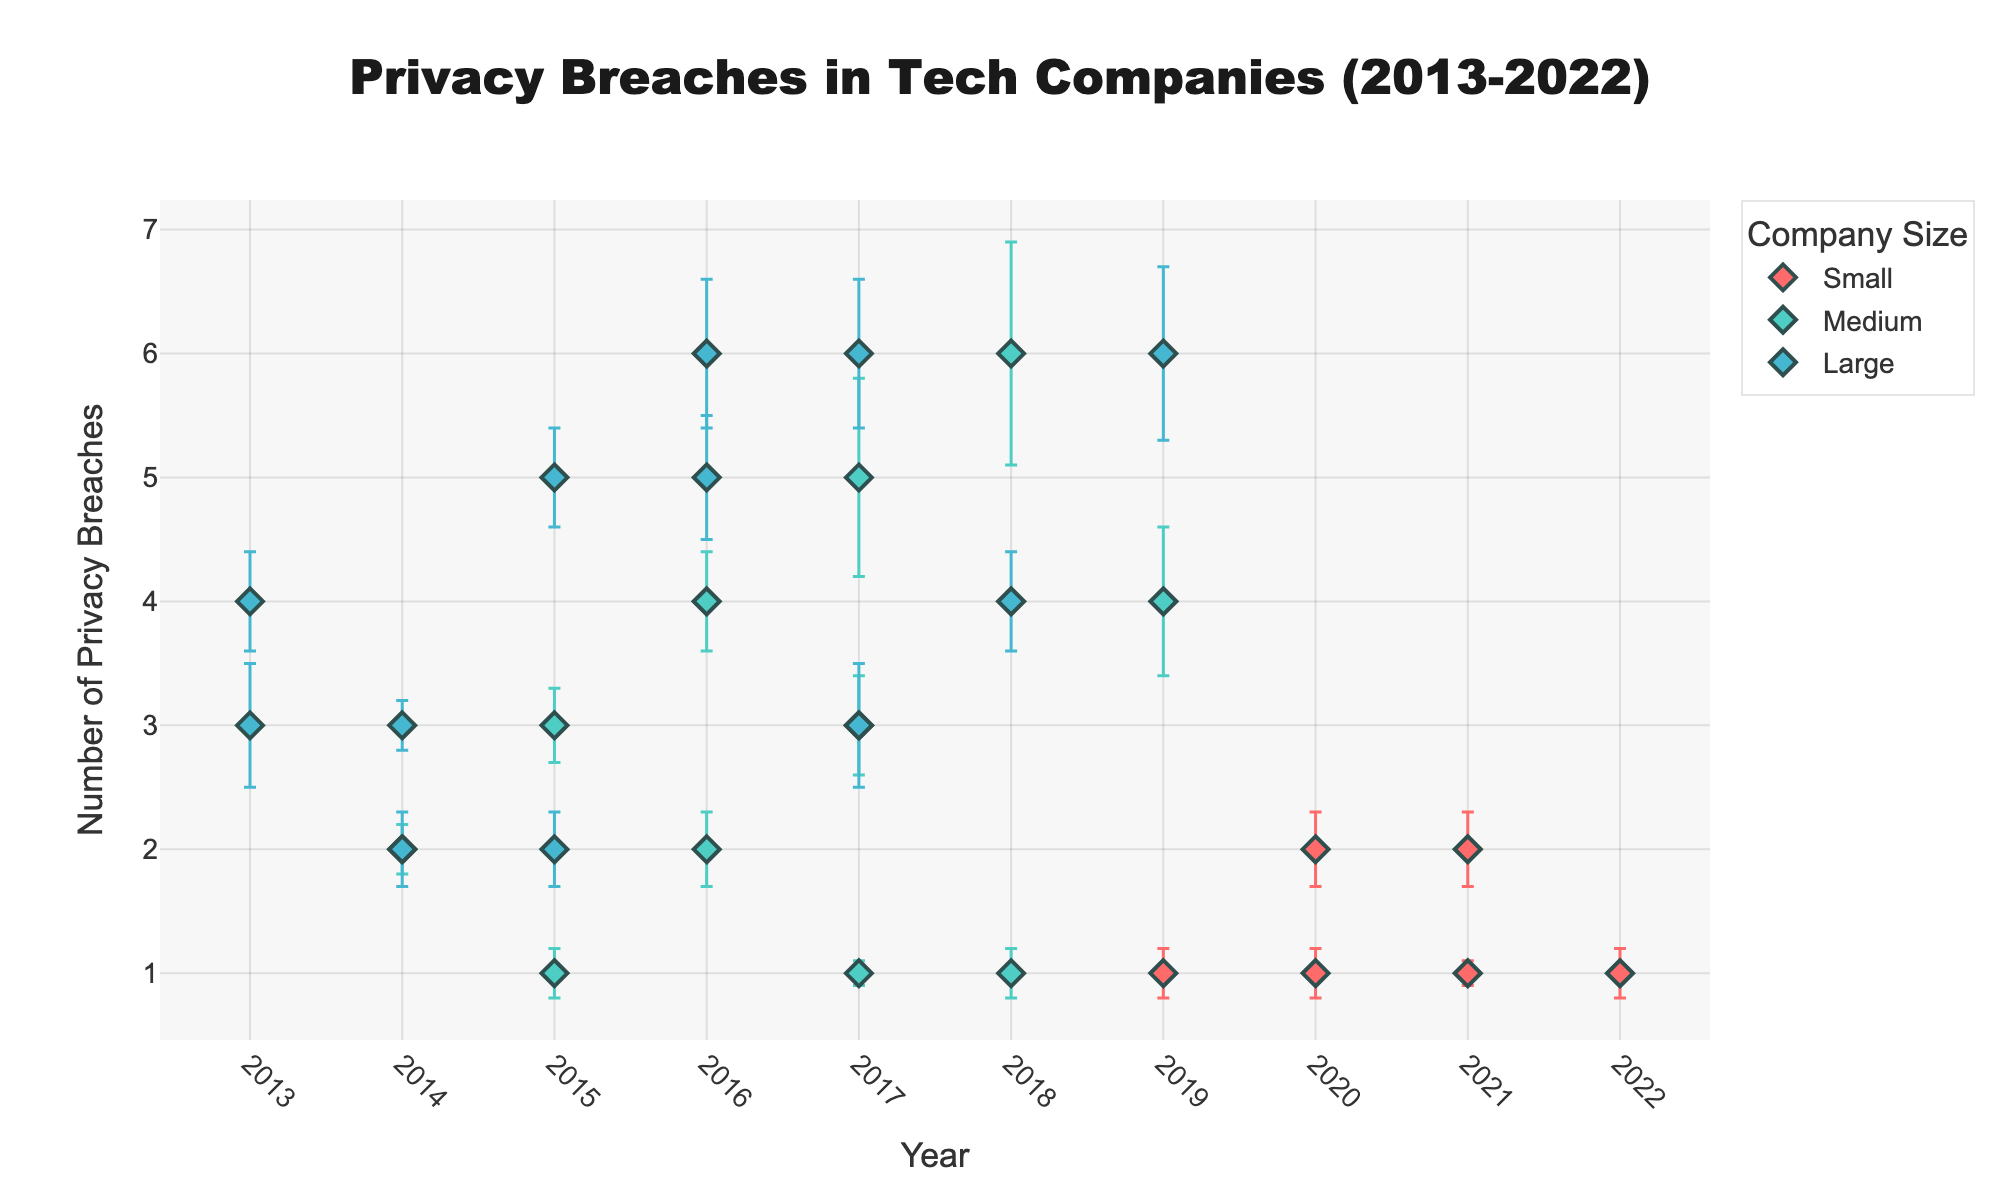what is the title of the plot? The title is usually displayed at the top of the plot, center-aligned. It provides a brief description of what the figure represents.
Answer: Privacy Breaches in Tech Companies (2013-2022) What is the y-axis title? The y-axis title is found along the vertical axis and indicates what is being measured in this direction.
Answer: Number of Privacy Breaches Which years show privacy breaches for small companies? The x-axis represents the years. Look at the plot and identify the years corresponding to the data points colored for small companies.
Answer: 2019, 2020, 2021, 2022 How many privacy breaches did Facebook have in 2016? Find the data point for Facebook (large company size) in 2016 on the x-axis and refer to the y-axis value at that point.
Answer: 6 Which company size had the lowest privacy breaches in 2017? Compare the data points for different company sizes for the year 2017 on the x-axis and determine which has the lowest value on the y-axis.
Answer: Medium What is the average number of privacy breaches for Google from 2013 to 2017? Find Google's privacy breaches data points for each year from 2013 to 2017 and calculate the average: (4+3+2+5+6)/5 = 20/5.
Answer: 4 Which company had the highest privacy breaches in 2019? Look for the data points belonging to different companies for the year 2019, identify the one with the highest y-axis value.
Answer: Alibaba In which year does Equifax have the highest privacy breaches and what is the value? Look at the data points for Equifax (medium company size) across the years and determine the year with the highest y-axis value and the corresponding number.
Answer: 2018, 6 How does the privacy breach trend for medium-sized companies change over time? Observe the trend line formed by the data points for medium-sized companies and describe the general pattern in the number of breaches over the years.
Answer: Fluctuating How does the error in privacy breaches for Alibaba in 2017 compare to its breaches in 2019? Look at the error bars for Alibaba's data points in 2017 and 2019 and compare their lengths.
Answer: Smaller in 2017 